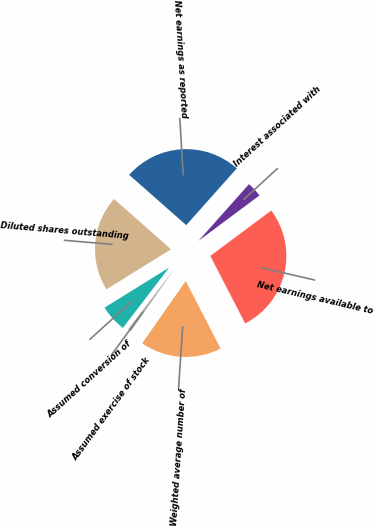<chart> <loc_0><loc_0><loc_500><loc_500><pie_chart><fcel>Net earnings as reported<fcel>Interest associated with<fcel>Net earnings available to<fcel>Weighted average number of<fcel>Assumed exercise of stock<fcel>Assumed conversion of<fcel>Diluted shares outstanding<nl><fcel>25.08%<fcel>3.23%<fcel>27.61%<fcel>17.29%<fcel>0.7%<fcel>5.76%<fcel>20.34%<nl></chart> 